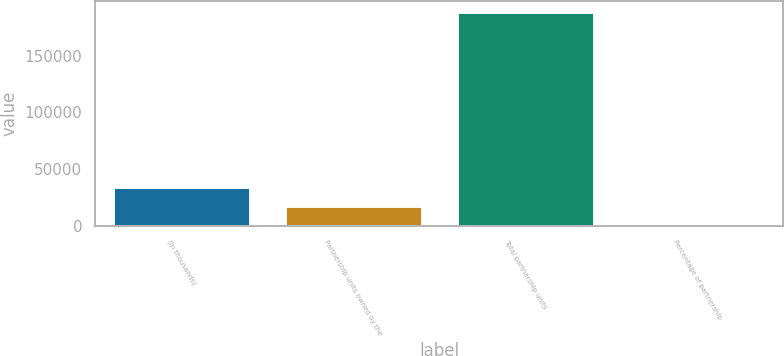Convert chart. <chart><loc_0><loc_0><loc_500><loc_500><bar_chart><fcel>(in thousands)<fcel>Partnership units owned by the<fcel>Total partnership units<fcel>Percentage of partnership<nl><fcel>34422.8<fcel>17261.3<fcel>188527<fcel>99.8<nl></chart> 